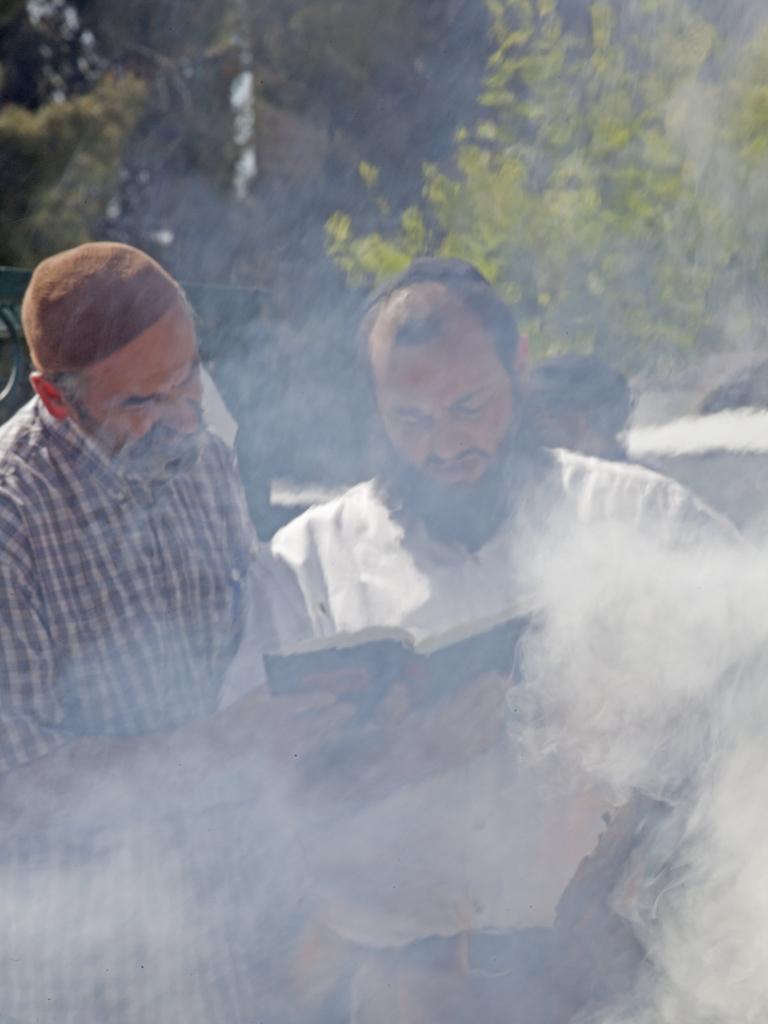Describe this image in one or two sentences. In this image is the foreground there are two persons who are standing and one person is holding a book, in the background there are some trees and there is a fog. 